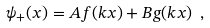<formula> <loc_0><loc_0><loc_500><loc_500>\psi _ { + } ( x ) = A f ( k x ) + B g ( k x ) \ ,</formula> 